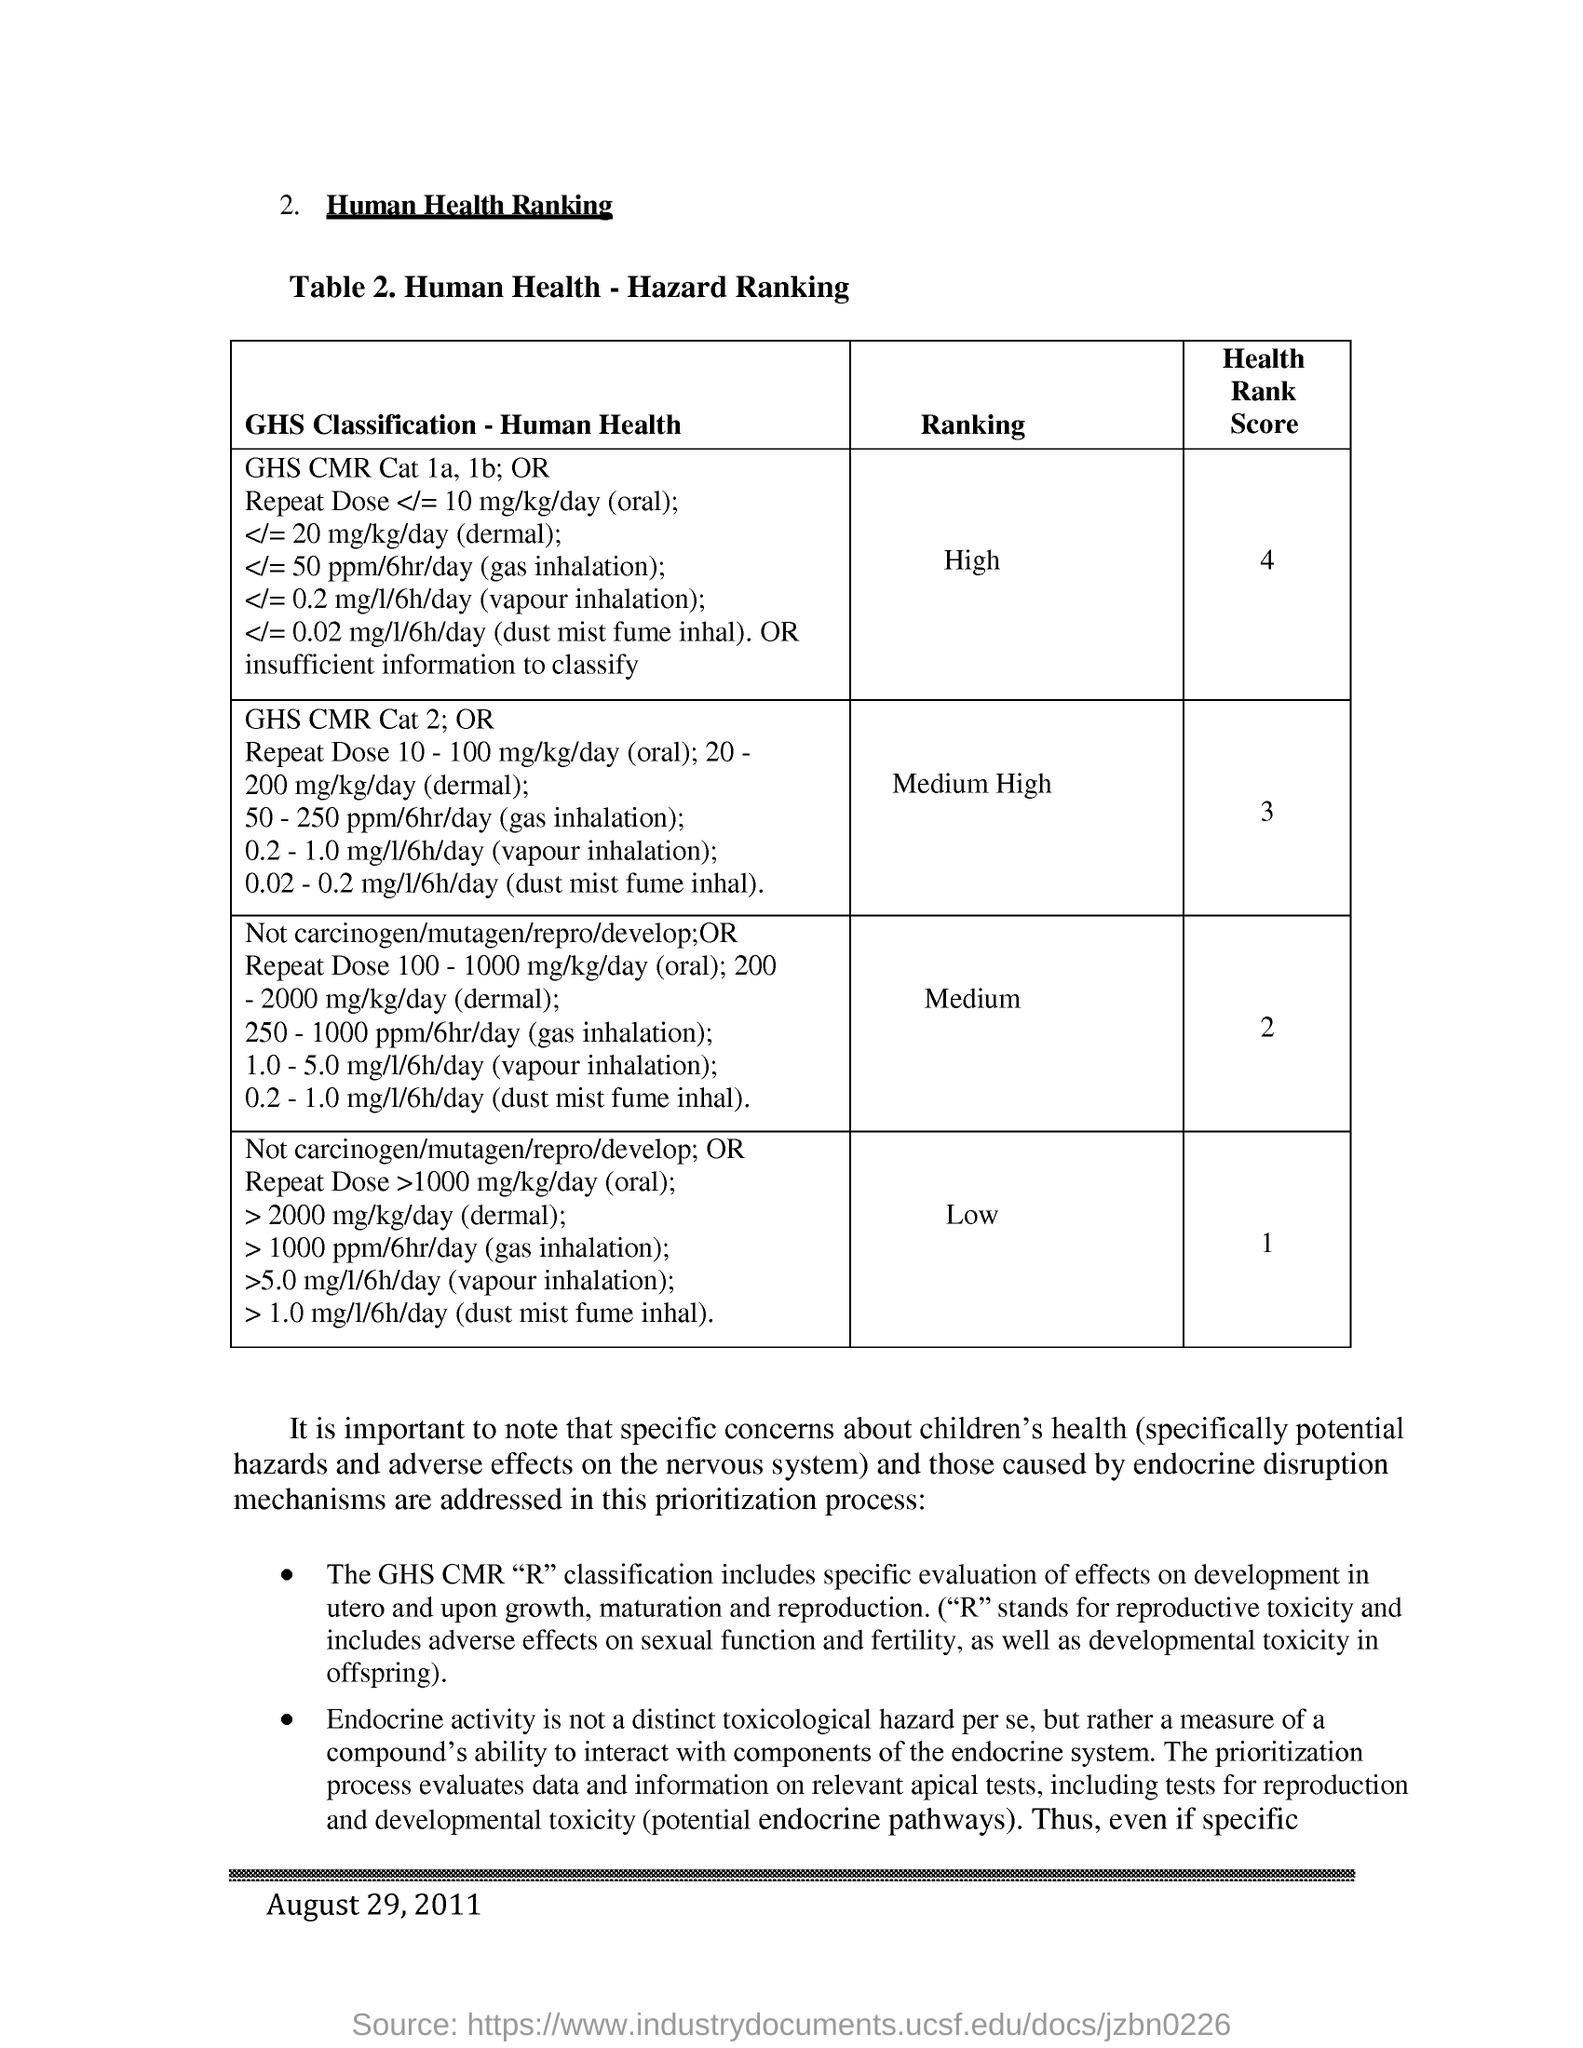Outline some significant characteristics in this image. The Health Rank Score is medium-high, which indicates that the health of the population in this region is somewhat high compared to other regions. The score is 3 out of 10. The Health Rank Score is ranked as 1, indicating that the health outcomes in this region are low. The date mentioned in this document is August 29, 2011. The heading of this document is 'Human Health Ranking.' 